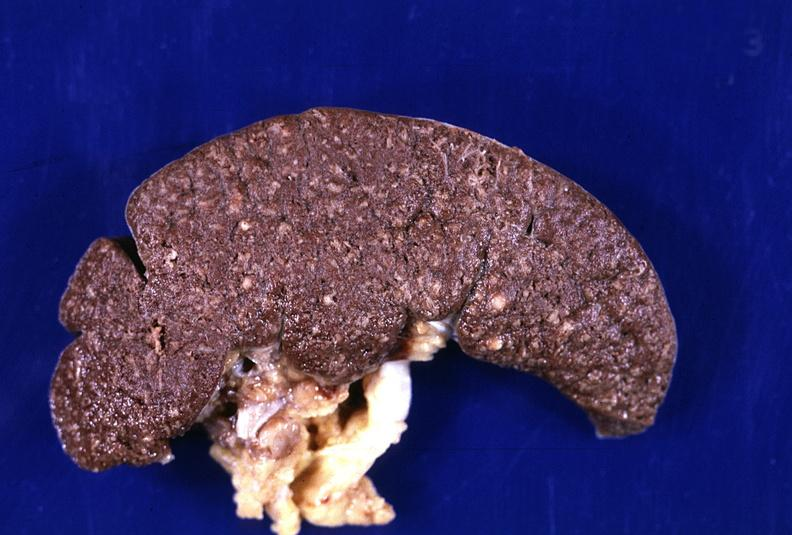s lymphangiomatosis generalized present?
Answer the question using a single word or phrase. No 